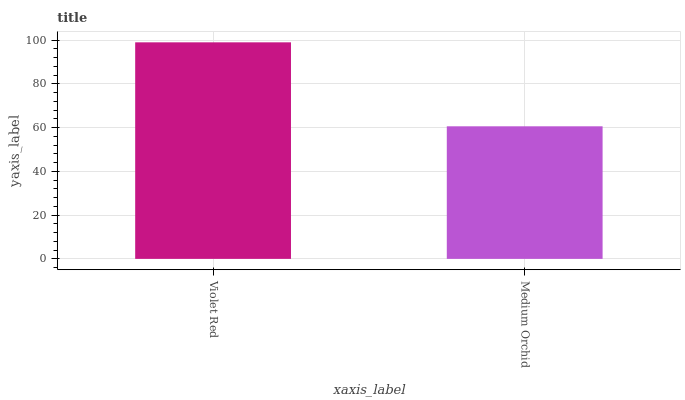Is Medium Orchid the maximum?
Answer yes or no. No. Is Violet Red greater than Medium Orchid?
Answer yes or no. Yes. Is Medium Orchid less than Violet Red?
Answer yes or no. Yes. Is Medium Orchid greater than Violet Red?
Answer yes or no. No. Is Violet Red less than Medium Orchid?
Answer yes or no. No. Is Violet Red the high median?
Answer yes or no. Yes. Is Medium Orchid the low median?
Answer yes or no. Yes. Is Medium Orchid the high median?
Answer yes or no. No. Is Violet Red the low median?
Answer yes or no. No. 